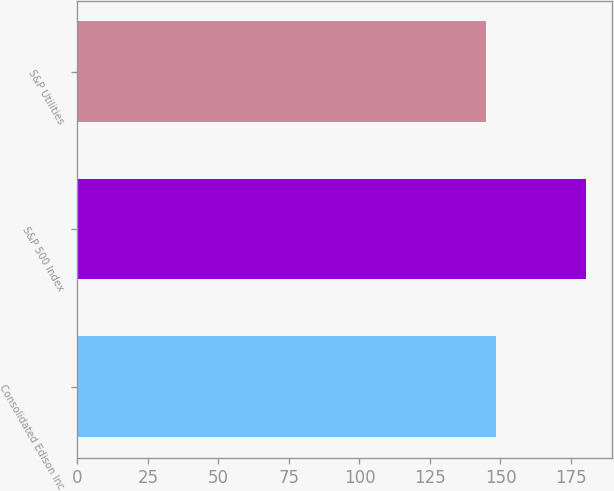<chart> <loc_0><loc_0><loc_500><loc_500><bar_chart><fcel>Consolidated Edison Inc<fcel>S&P 500 Index<fcel>S&P Utilities<nl><fcel>148.56<fcel>180.44<fcel>145.02<nl></chart> 